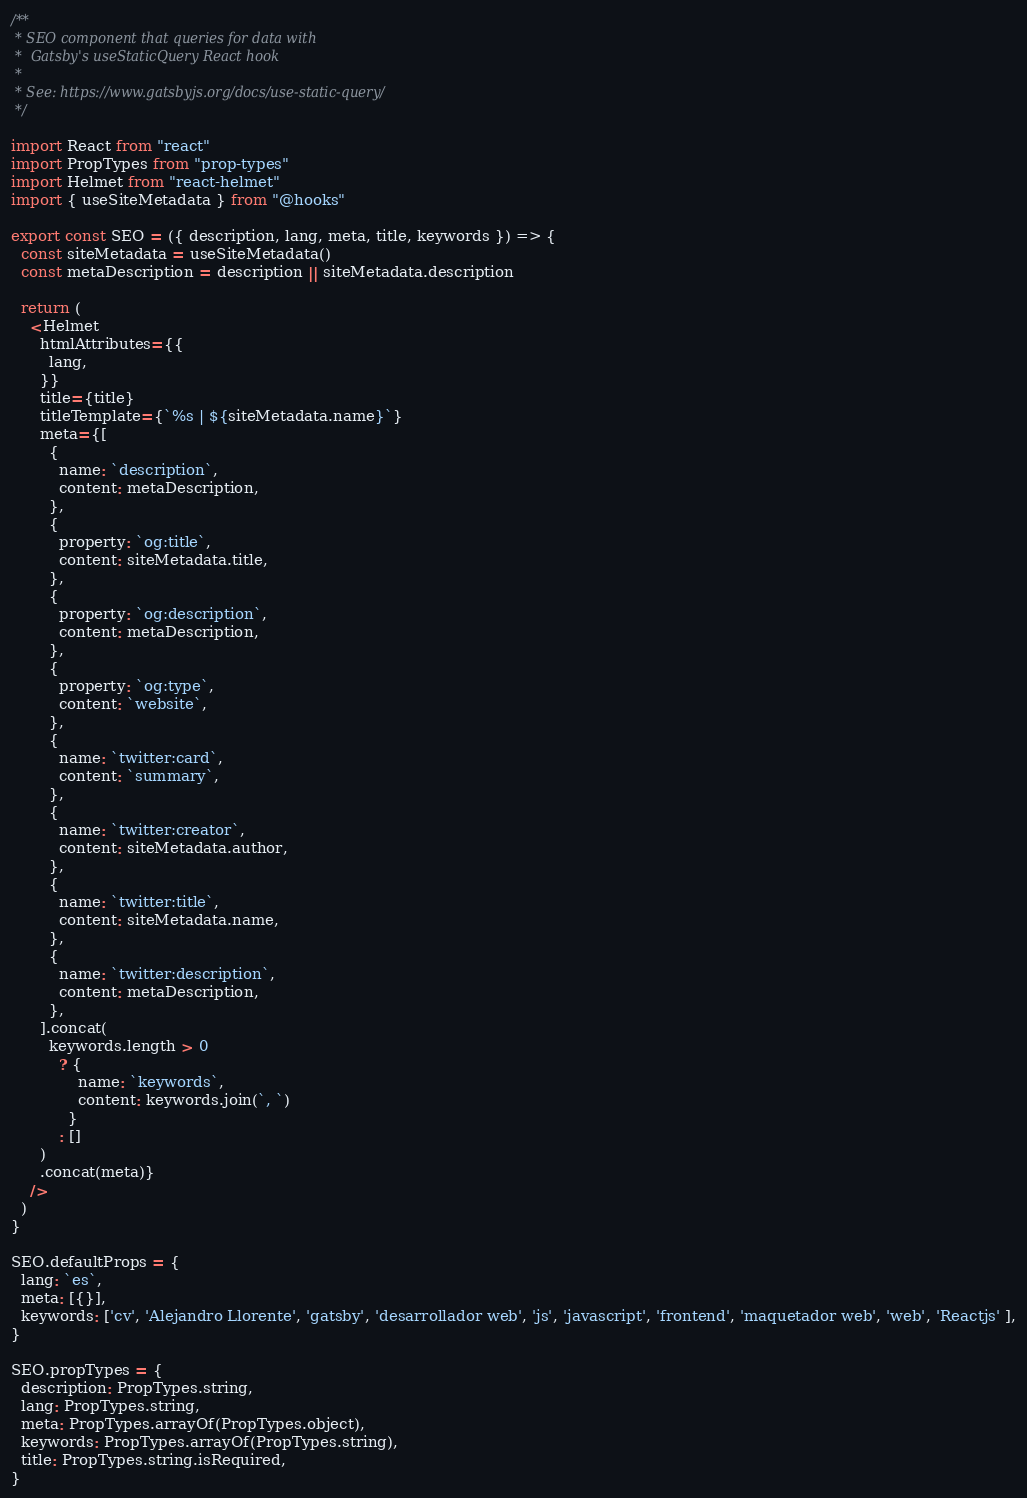Convert code to text. <code><loc_0><loc_0><loc_500><loc_500><_JavaScript_>/**
 * SEO component that queries for data with
 *  Gatsby's useStaticQuery React hook
 *
 * See: https://www.gatsbyjs.org/docs/use-static-query/
 */

import React from "react"
import PropTypes from "prop-types"
import Helmet from "react-helmet"
import { useSiteMetadata } from "@hooks"

export const SEO = ({ description, lang, meta, title, keywords }) => {
  const siteMetadata = useSiteMetadata()
  const metaDescription = description || siteMetadata.description

  return (
    <Helmet
      htmlAttributes={{
        lang,
      }}
      title={title}
      titleTemplate={`%s | ${siteMetadata.name}`}
      meta={[
        {
          name: `description`,
          content: metaDescription,
        },
        {
          property: `og:title`,
          content: siteMetadata.title,
        },
        {
          property: `og:description`,
          content: metaDescription,
        },
        {
          property: `og:type`,
          content: `website`,
        },
        {
          name: `twitter:card`,
          content: `summary`,
        },
        {
          name: `twitter:creator`,
          content: siteMetadata.author,
        },
        {
          name: `twitter:title`,
          content: siteMetadata.name,
        },
        {
          name: `twitter:description`,
          content: metaDescription,
        },
      ].concat(
        keywords.length > 0
          ? {
              name: `keywords`,
              content: keywords.join(`, `)
            }
          : []
      )
      .concat(meta)}
    />
  )
}

SEO.defaultProps = {
  lang: `es`,
  meta: [{}],
  keywords: ['cv', 'Alejandro Llorente', 'gatsby', 'desarrollador web', 'js', 'javascript', 'frontend', 'maquetador web', 'web', 'Reactjs' ],
}

SEO.propTypes = {
  description: PropTypes.string,
  lang: PropTypes.string,
  meta: PropTypes.arrayOf(PropTypes.object),
  keywords: PropTypes.arrayOf(PropTypes.string),
  title: PropTypes.string.isRequired,
}
</code> 